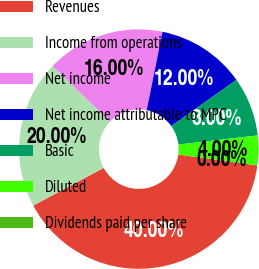Convert chart. <chart><loc_0><loc_0><loc_500><loc_500><pie_chart><fcel>Revenues<fcel>Income from operations<fcel>Net income<fcel>Net income attributable to MPC<fcel>Basic<fcel>Diluted<fcel>Dividends paid per share<nl><fcel>40.0%<fcel>20.0%<fcel>16.0%<fcel>12.0%<fcel>8.0%<fcel>4.0%<fcel>0.0%<nl></chart> 